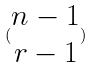Convert formula to latex. <formula><loc_0><loc_0><loc_500><loc_500>( \begin{matrix} n - 1 \\ r - 1 \end{matrix} )</formula> 